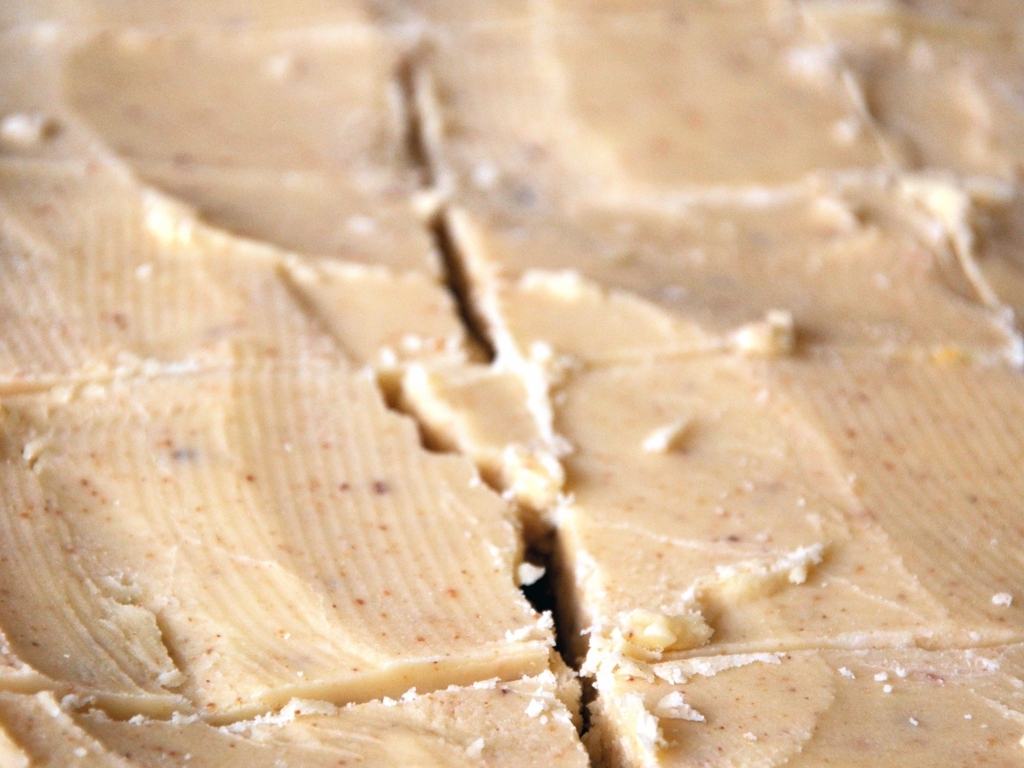What am I looking at here? Can you describe the object in this image? You are looking at a close-up image of what appears to be a spreadable substance, possibly butter or a spread, which has a smooth texture with some knife streaks and crumbs visible on the surface. 